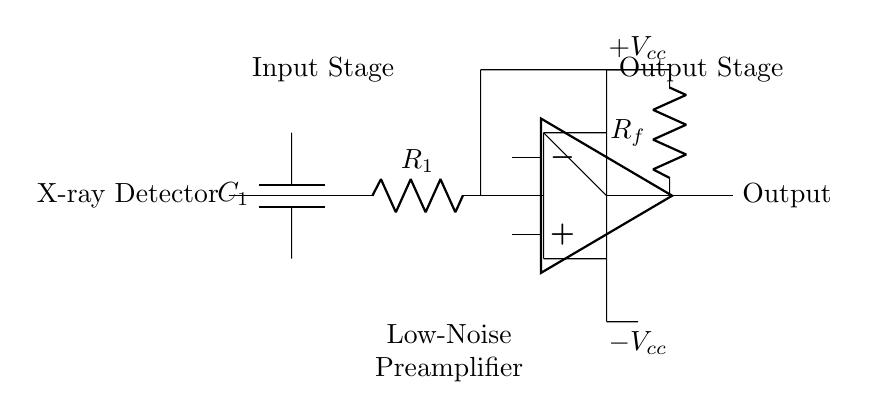What component is used to block DC in this circuit? The capacitor labeled C1 is used to block DC while allowing AC signals to pass through. This is a typical function of capacitors in amplifier circuits.
Answer: C1 What is the role of the resistor labeled R1? The resistor R1 serves as part of the input stage, helping to set the input impedance of the circuit and allowing for the proper signal conditioning before amplification.
Answer: Input impedance What type of amplifier is represented in this circuit? The circuit shows a low-noise preamplifier designed for enhancing signals from an X-ray detector, focusing on reducing additional noise during signal processing.
Answer: Low-noise preamplifier What is the feedback resistor in this amplifier setup? The feedback resistor is labeled Rf, and it determines the gain of the operational amplifier by feeding a portion of the output signal back to its input.
Answer: Rf What are the power supply requirements for the operational amplifier? The operational amplifier requires both a positive supply voltage labeled Vcc and a negative supply voltage labeled -Vcc, allowing it to amplify both positive and negative signals.
Answer: +Vcc, -Vcc How does this circuit enhance the signals from the X-ray detector? The circuit amplifies the weak electrical signals generated by the X-ray detector and reduces noise, thus improving the overall signal quality and fidelity before further processing.
Answer: Signal enhancement What type of component is the operational amplifier in this circuit? The operational amplifier is categorized as an analog component that performs mathematical operations on the input signals, primarily amplification in this case.
Answer: Analog component 